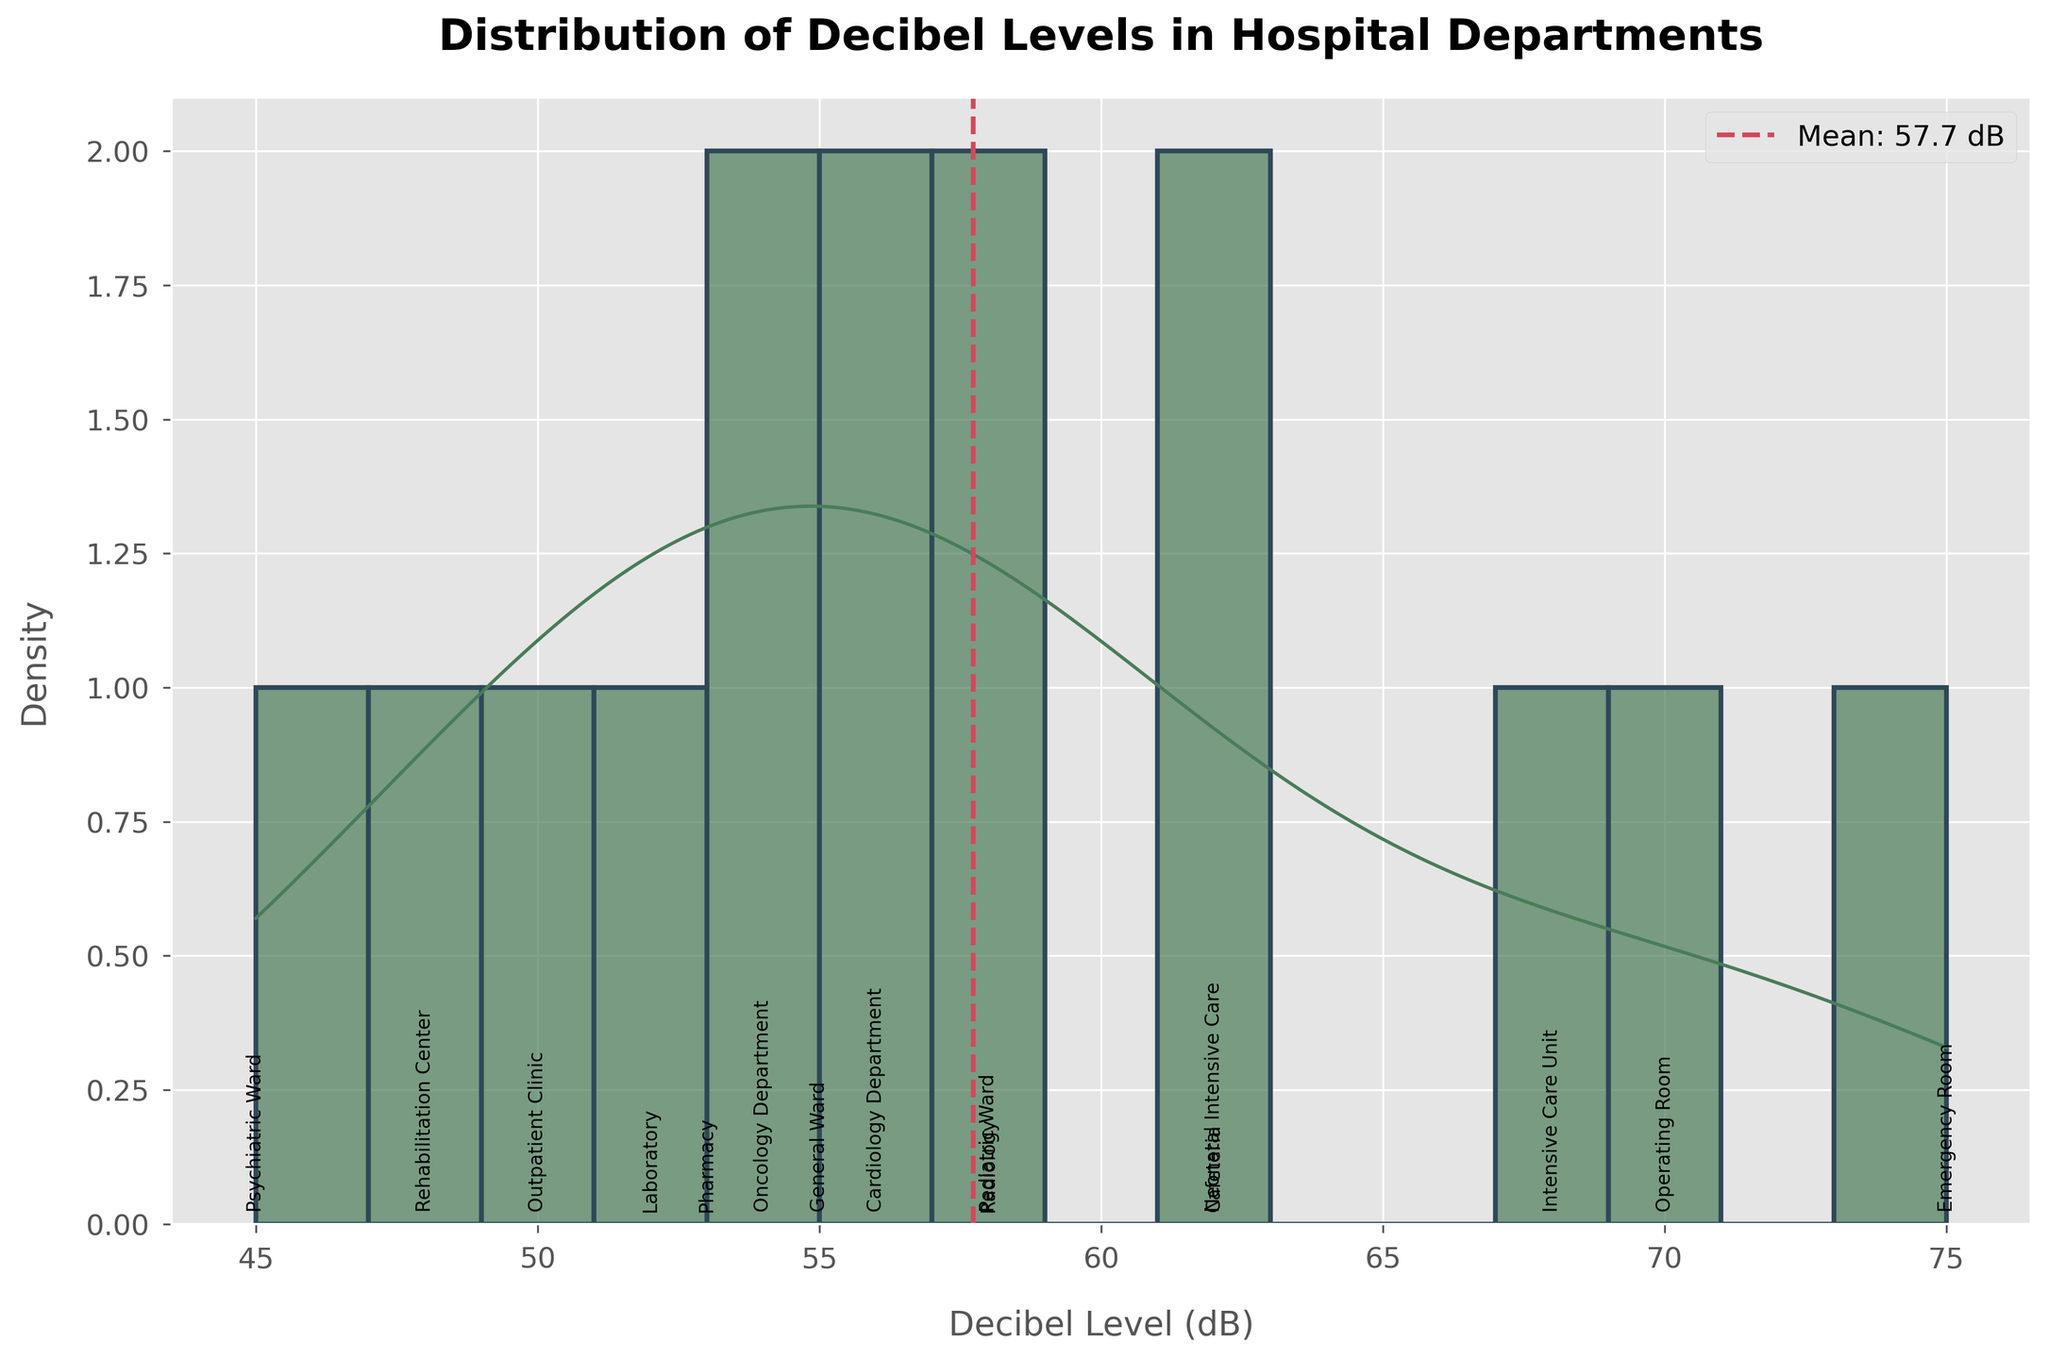What is the title of the plot? The title of the plot is usually positioned at the top of the figure. In this case, the title reads "Distribution of Decibel Levels in Hospital Departments".
Answer: Distribution of Decibel Levels in Hospital Departments Which department has the highest decibel level? The annotations above the histogram bars indicate the department names. The bar at 75 dB is labeled "Emergency Room", indicating the highest decibel level.
Answer: Emergency Room What is the mean decibel level indicated in the plot? The mean decibel level is marked with a dashed vertical line on the plot, accompanied by a label. The label reads "Mean: 57.7 dB".
Answer: 57.7 dB How do decibel levels in the Psychiatric Ward compare to the General Ward? By looking at the annotated labels, the Psychiatric Ward has a decibel level of 45 dB and the General Ward has 55 dB. The decibel level in the Psychiatric Ward is lower.
Answer: Psychiatric Ward is lower What is the decibel level range where most departments are concentrated? The KDE curve indicates areas of high density. Most departments cluster between 50 dB and 60 dB, where the KDE curve peaks.
Answer: 50 dB to 60 dB How does the density curve help in understanding the distribution of the data? The density curve (KDE) provides a smooth estimate of the distribution, allowing for identification of areas with high concentration of decibel levels. It helps visualize where most data points lie beyond just the histogram bars.
Answer: Shows data concentration What is the general trend between decibel levels and patient well-being scores in the departments? Although not directly plotted, one can infer from the labels that lower decibel levels often have higher patient well-being scores (as seen in departments like the Psychiatric Ward and Rehabilitation Center with lower decibels and higher scores).
Answer: Lower decibel levels, higher well-being Which departments have decibel levels below the mean? The departments with decibel levels below the mean (57.7 dB) can be identified from the histogram and annotations, including Pharmacy (53 dB), Psychiatry Ward (45 dB), and Outpatient Clinic (50 dB).
Answer: Pharmacy, Psychiatry Ward, Outpatient Clinic Are there any departments where the decibel level is the same? From the annotations, both the Neonatal Intensive Care and Cafeteria share a decibel level of 62 dB.
Answer: Neonatal Intensive Care and Cafeteria Which department has the lowest decibel level? The annotations indicate a decibel level of 45 dB for the Psychiatric Ward, which is the lowest among all departments.
Answer: Psychiatric Ward 